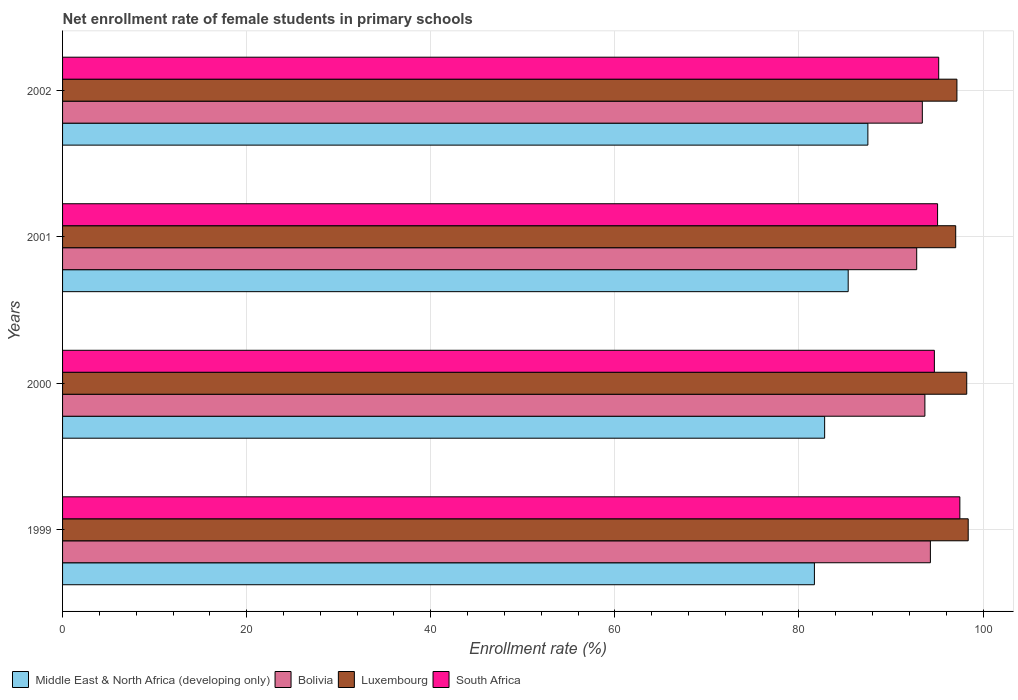How many different coloured bars are there?
Your answer should be compact. 4. How many groups of bars are there?
Your response must be concise. 4. How many bars are there on the 3rd tick from the top?
Your answer should be compact. 4. What is the label of the 3rd group of bars from the top?
Keep it short and to the point. 2000. What is the net enrollment rate of female students in primary schools in Middle East & North Africa (developing only) in 2000?
Offer a very short reply. 82.79. Across all years, what is the maximum net enrollment rate of female students in primary schools in Bolivia?
Provide a succinct answer. 94.28. Across all years, what is the minimum net enrollment rate of female students in primary schools in South Africa?
Ensure brevity in your answer.  94.71. In which year was the net enrollment rate of female students in primary schools in Middle East & North Africa (developing only) maximum?
Provide a short and direct response. 2002. In which year was the net enrollment rate of female students in primary schools in South Africa minimum?
Provide a succinct answer. 2000. What is the total net enrollment rate of female students in primary schools in Middle East & North Africa (developing only) in the graph?
Your response must be concise. 337.3. What is the difference between the net enrollment rate of female students in primary schools in Luxembourg in 2000 and that in 2001?
Your answer should be very brief. 1.2. What is the difference between the net enrollment rate of female students in primary schools in Luxembourg in 2000 and the net enrollment rate of female students in primary schools in Middle East & North Africa (developing only) in 2002?
Provide a short and direct response. 10.74. What is the average net enrollment rate of female students in primary schools in Luxembourg per year?
Offer a terse response. 97.7. In the year 2001, what is the difference between the net enrollment rate of female students in primary schools in Luxembourg and net enrollment rate of female students in primary schools in Middle East & North Africa (developing only)?
Make the answer very short. 11.68. What is the ratio of the net enrollment rate of female students in primary schools in Bolivia in 1999 to that in 2001?
Keep it short and to the point. 1.02. Is the net enrollment rate of female students in primary schools in Middle East & North Africa (developing only) in 1999 less than that in 2001?
Provide a succinct answer. Yes. Is the difference between the net enrollment rate of female students in primary schools in Luxembourg in 2001 and 2002 greater than the difference between the net enrollment rate of female students in primary schools in Middle East & North Africa (developing only) in 2001 and 2002?
Make the answer very short. Yes. What is the difference between the highest and the second highest net enrollment rate of female students in primary schools in Luxembourg?
Your answer should be very brief. 0.16. What is the difference between the highest and the lowest net enrollment rate of female students in primary schools in Luxembourg?
Give a very brief answer. 1.36. In how many years, is the net enrollment rate of female students in primary schools in Luxembourg greater than the average net enrollment rate of female students in primary schools in Luxembourg taken over all years?
Provide a short and direct response. 2. Is the sum of the net enrollment rate of female students in primary schools in South Africa in 2000 and 2001 greater than the maximum net enrollment rate of female students in primary schools in Middle East & North Africa (developing only) across all years?
Your response must be concise. Yes. What does the 3rd bar from the top in 2002 represents?
Offer a terse response. Bolivia. What does the 3rd bar from the bottom in 1999 represents?
Your answer should be compact. Luxembourg. How many years are there in the graph?
Offer a terse response. 4. What is the difference between two consecutive major ticks on the X-axis?
Your response must be concise. 20. Does the graph contain grids?
Ensure brevity in your answer.  Yes. Where does the legend appear in the graph?
Offer a very short reply. Bottom left. How many legend labels are there?
Keep it short and to the point. 4. What is the title of the graph?
Keep it short and to the point. Net enrollment rate of female students in primary schools. Does "Switzerland" appear as one of the legend labels in the graph?
Make the answer very short. No. What is the label or title of the X-axis?
Make the answer very short. Enrollment rate (%). What is the label or title of the Y-axis?
Your response must be concise. Years. What is the Enrollment rate (%) of Middle East & North Africa (developing only) in 1999?
Provide a succinct answer. 81.68. What is the Enrollment rate (%) of Bolivia in 1999?
Make the answer very short. 94.28. What is the Enrollment rate (%) in Luxembourg in 1999?
Offer a very short reply. 98.39. What is the Enrollment rate (%) in South Africa in 1999?
Ensure brevity in your answer.  97.48. What is the Enrollment rate (%) in Middle East & North Africa (developing only) in 2000?
Your answer should be very brief. 82.79. What is the Enrollment rate (%) in Bolivia in 2000?
Provide a succinct answer. 93.68. What is the Enrollment rate (%) of Luxembourg in 2000?
Provide a short and direct response. 98.23. What is the Enrollment rate (%) in South Africa in 2000?
Provide a short and direct response. 94.71. What is the Enrollment rate (%) of Middle East & North Africa (developing only) in 2001?
Make the answer very short. 85.35. What is the Enrollment rate (%) of Bolivia in 2001?
Offer a very short reply. 92.79. What is the Enrollment rate (%) of Luxembourg in 2001?
Your answer should be very brief. 97.03. What is the Enrollment rate (%) in South Africa in 2001?
Keep it short and to the point. 95.06. What is the Enrollment rate (%) in Middle East & North Africa (developing only) in 2002?
Offer a very short reply. 87.49. What is the Enrollment rate (%) of Bolivia in 2002?
Make the answer very short. 93.4. What is the Enrollment rate (%) in Luxembourg in 2002?
Your answer should be compact. 97.16. What is the Enrollment rate (%) of South Africa in 2002?
Keep it short and to the point. 95.18. Across all years, what is the maximum Enrollment rate (%) of Middle East & North Africa (developing only)?
Provide a short and direct response. 87.49. Across all years, what is the maximum Enrollment rate (%) in Bolivia?
Your answer should be very brief. 94.28. Across all years, what is the maximum Enrollment rate (%) in Luxembourg?
Offer a very short reply. 98.39. Across all years, what is the maximum Enrollment rate (%) of South Africa?
Make the answer very short. 97.48. Across all years, what is the minimum Enrollment rate (%) in Middle East & North Africa (developing only)?
Ensure brevity in your answer.  81.68. Across all years, what is the minimum Enrollment rate (%) of Bolivia?
Give a very brief answer. 92.79. Across all years, what is the minimum Enrollment rate (%) in Luxembourg?
Your response must be concise. 97.03. Across all years, what is the minimum Enrollment rate (%) of South Africa?
Keep it short and to the point. 94.71. What is the total Enrollment rate (%) of Middle East & North Africa (developing only) in the graph?
Ensure brevity in your answer.  337.3. What is the total Enrollment rate (%) of Bolivia in the graph?
Offer a terse response. 374.16. What is the total Enrollment rate (%) in Luxembourg in the graph?
Your response must be concise. 390.8. What is the total Enrollment rate (%) of South Africa in the graph?
Provide a short and direct response. 382.43. What is the difference between the Enrollment rate (%) in Middle East & North Africa (developing only) in 1999 and that in 2000?
Give a very brief answer. -1.11. What is the difference between the Enrollment rate (%) of Bolivia in 1999 and that in 2000?
Provide a short and direct response. 0.6. What is the difference between the Enrollment rate (%) in Luxembourg in 1999 and that in 2000?
Ensure brevity in your answer.  0.16. What is the difference between the Enrollment rate (%) of South Africa in 1999 and that in 2000?
Keep it short and to the point. 2.77. What is the difference between the Enrollment rate (%) in Middle East & North Africa (developing only) in 1999 and that in 2001?
Make the answer very short. -3.67. What is the difference between the Enrollment rate (%) of Bolivia in 1999 and that in 2001?
Your answer should be compact. 1.49. What is the difference between the Enrollment rate (%) in Luxembourg in 1999 and that in 2001?
Your answer should be very brief. 1.36. What is the difference between the Enrollment rate (%) in South Africa in 1999 and that in 2001?
Your response must be concise. 2.42. What is the difference between the Enrollment rate (%) in Middle East & North Africa (developing only) in 1999 and that in 2002?
Your answer should be compact. -5.81. What is the difference between the Enrollment rate (%) of Bolivia in 1999 and that in 2002?
Your answer should be compact. 0.88. What is the difference between the Enrollment rate (%) in Luxembourg in 1999 and that in 2002?
Provide a succinct answer. 1.23. What is the difference between the Enrollment rate (%) in South Africa in 1999 and that in 2002?
Make the answer very short. 2.3. What is the difference between the Enrollment rate (%) in Middle East & North Africa (developing only) in 2000 and that in 2001?
Ensure brevity in your answer.  -2.56. What is the difference between the Enrollment rate (%) of Bolivia in 2000 and that in 2001?
Your answer should be very brief. 0.89. What is the difference between the Enrollment rate (%) in Luxembourg in 2000 and that in 2001?
Provide a succinct answer. 1.2. What is the difference between the Enrollment rate (%) of South Africa in 2000 and that in 2001?
Offer a very short reply. -0.35. What is the difference between the Enrollment rate (%) of Middle East & North Africa (developing only) in 2000 and that in 2002?
Your answer should be compact. -4.7. What is the difference between the Enrollment rate (%) in Bolivia in 2000 and that in 2002?
Your answer should be compact. 0.28. What is the difference between the Enrollment rate (%) in Luxembourg in 2000 and that in 2002?
Your response must be concise. 1.07. What is the difference between the Enrollment rate (%) of South Africa in 2000 and that in 2002?
Your answer should be compact. -0.47. What is the difference between the Enrollment rate (%) of Middle East & North Africa (developing only) in 2001 and that in 2002?
Offer a terse response. -2.14. What is the difference between the Enrollment rate (%) in Bolivia in 2001 and that in 2002?
Ensure brevity in your answer.  -0.61. What is the difference between the Enrollment rate (%) in Luxembourg in 2001 and that in 2002?
Ensure brevity in your answer.  -0.13. What is the difference between the Enrollment rate (%) in South Africa in 2001 and that in 2002?
Your response must be concise. -0.12. What is the difference between the Enrollment rate (%) in Middle East & North Africa (developing only) in 1999 and the Enrollment rate (%) in Bolivia in 2000?
Offer a terse response. -12. What is the difference between the Enrollment rate (%) in Middle East & North Africa (developing only) in 1999 and the Enrollment rate (%) in Luxembourg in 2000?
Your answer should be very brief. -16.55. What is the difference between the Enrollment rate (%) of Middle East & North Africa (developing only) in 1999 and the Enrollment rate (%) of South Africa in 2000?
Provide a short and direct response. -13.03. What is the difference between the Enrollment rate (%) of Bolivia in 1999 and the Enrollment rate (%) of Luxembourg in 2000?
Your answer should be very brief. -3.95. What is the difference between the Enrollment rate (%) of Bolivia in 1999 and the Enrollment rate (%) of South Africa in 2000?
Give a very brief answer. -0.43. What is the difference between the Enrollment rate (%) of Luxembourg in 1999 and the Enrollment rate (%) of South Africa in 2000?
Your answer should be very brief. 3.68. What is the difference between the Enrollment rate (%) in Middle East & North Africa (developing only) in 1999 and the Enrollment rate (%) in Bolivia in 2001?
Provide a short and direct response. -11.11. What is the difference between the Enrollment rate (%) of Middle East & North Africa (developing only) in 1999 and the Enrollment rate (%) of Luxembourg in 2001?
Give a very brief answer. -15.35. What is the difference between the Enrollment rate (%) of Middle East & North Africa (developing only) in 1999 and the Enrollment rate (%) of South Africa in 2001?
Provide a succinct answer. -13.38. What is the difference between the Enrollment rate (%) in Bolivia in 1999 and the Enrollment rate (%) in Luxembourg in 2001?
Provide a short and direct response. -2.75. What is the difference between the Enrollment rate (%) of Bolivia in 1999 and the Enrollment rate (%) of South Africa in 2001?
Your response must be concise. -0.78. What is the difference between the Enrollment rate (%) of Luxembourg in 1999 and the Enrollment rate (%) of South Africa in 2001?
Offer a terse response. 3.33. What is the difference between the Enrollment rate (%) in Middle East & North Africa (developing only) in 1999 and the Enrollment rate (%) in Bolivia in 2002?
Your response must be concise. -11.72. What is the difference between the Enrollment rate (%) of Middle East & North Africa (developing only) in 1999 and the Enrollment rate (%) of Luxembourg in 2002?
Keep it short and to the point. -15.48. What is the difference between the Enrollment rate (%) of Middle East & North Africa (developing only) in 1999 and the Enrollment rate (%) of South Africa in 2002?
Make the answer very short. -13.5. What is the difference between the Enrollment rate (%) of Bolivia in 1999 and the Enrollment rate (%) of Luxembourg in 2002?
Ensure brevity in your answer.  -2.88. What is the difference between the Enrollment rate (%) in Bolivia in 1999 and the Enrollment rate (%) in South Africa in 2002?
Your answer should be compact. -0.9. What is the difference between the Enrollment rate (%) in Luxembourg in 1999 and the Enrollment rate (%) in South Africa in 2002?
Make the answer very short. 3.21. What is the difference between the Enrollment rate (%) of Middle East & North Africa (developing only) in 2000 and the Enrollment rate (%) of Bolivia in 2001?
Provide a succinct answer. -10. What is the difference between the Enrollment rate (%) of Middle East & North Africa (developing only) in 2000 and the Enrollment rate (%) of Luxembourg in 2001?
Give a very brief answer. -14.24. What is the difference between the Enrollment rate (%) of Middle East & North Africa (developing only) in 2000 and the Enrollment rate (%) of South Africa in 2001?
Provide a succinct answer. -12.27. What is the difference between the Enrollment rate (%) of Bolivia in 2000 and the Enrollment rate (%) of Luxembourg in 2001?
Give a very brief answer. -3.35. What is the difference between the Enrollment rate (%) of Bolivia in 2000 and the Enrollment rate (%) of South Africa in 2001?
Make the answer very short. -1.38. What is the difference between the Enrollment rate (%) of Luxembourg in 2000 and the Enrollment rate (%) of South Africa in 2001?
Provide a succinct answer. 3.17. What is the difference between the Enrollment rate (%) in Middle East & North Africa (developing only) in 2000 and the Enrollment rate (%) in Bolivia in 2002?
Your response must be concise. -10.61. What is the difference between the Enrollment rate (%) in Middle East & North Africa (developing only) in 2000 and the Enrollment rate (%) in Luxembourg in 2002?
Give a very brief answer. -14.37. What is the difference between the Enrollment rate (%) in Middle East & North Africa (developing only) in 2000 and the Enrollment rate (%) in South Africa in 2002?
Your answer should be very brief. -12.39. What is the difference between the Enrollment rate (%) of Bolivia in 2000 and the Enrollment rate (%) of Luxembourg in 2002?
Provide a short and direct response. -3.48. What is the difference between the Enrollment rate (%) in Bolivia in 2000 and the Enrollment rate (%) in South Africa in 2002?
Your answer should be compact. -1.5. What is the difference between the Enrollment rate (%) of Luxembourg in 2000 and the Enrollment rate (%) of South Africa in 2002?
Provide a succinct answer. 3.04. What is the difference between the Enrollment rate (%) in Middle East & North Africa (developing only) in 2001 and the Enrollment rate (%) in Bolivia in 2002?
Make the answer very short. -8.05. What is the difference between the Enrollment rate (%) in Middle East & North Africa (developing only) in 2001 and the Enrollment rate (%) in Luxembourg in 2002?
Your answer should be compact. -11.81. What is the difference between the Enrollment rate (%) in Middle East & North Africa (developing only) in 2001 and the Enrollment rate (%) in South Africa in 2002?
Keep it short and to the point. -9.83. What is the difference between the Enrollment rate (%) of Bolivia in 2001 and the Enrollment rate (%) of Luxembourg in 2002?
Offer a terse response. -4.37. What is the difference between the Enrollment rate (%) in Bolivia in 2001 and the Enrollment rate (%) in South Africa in 2002?
Give a very brief answer. -2.39. What is the difference between the Enrollment rate (%) in Luxembourg in 2001 and the Enrollment rate (%) in South Africa in 2002?
Make the answer very short. 1.85. What is the average Enrollment rate (%) of Middle East & North Africa (developing only) per year?
Offer a very short reply. 84.33. What is the average Enrollment rate (%) of Bolivia per year?
Provide a short and direct response. 93.54. What is the average Enrollment rate (%) of Luxembourg per year?
Make the answer very short. 97.7. What is the average Enrollment rate (%) in South Africa per year?
Offer a terse response. 95.61. In the year 1999, what is the difference between the Enrollment rate (%) in Middle East & North Africa (developing only) and Enrollment rate (%) in Bolivia?
Keep it short and to the point. -12.6. In the year 1999, what is the difference between the Enrollment rate (%) in Middle East & North Africa (developing only) and Enrollment rate (%) in Luxembourg?
Offer a very short reply. -16.71. In the year 1999, what is the difference between the Enrollment rate (%) of Middle East & North Africa (developing only) and Enrollment rate (%) of South Africa?
Your answer should be compact. -15.8. In the year 1999, what is the difference between the Enrollment rate (%) of Bolivia and Enrollment rate (%) of Luxembourg?
Keep it short and to the point. -4.11. In the year 1999, what is the difference between the Enrollment rate (%) of Bolivia and Enrollment rate (%) of South Africa?
Make the answer very short. -3.2. In the year 1999, what is the difference between the Enrollment rate (%) in Luxembourg and Enrollment rate (%) in South Africa?
Give a very brief answer. 0.91. In the year 2000, what is the difference between the Enrollment rate (%) of Middle East & North Africa (developing only) and Enrollment rate (%) of Bolivia?
Give a very brief answer. -10.89. In the year 2000, what is the difference between the Enrollment rate (%) in Middle East & North Africa (developing only) and Enrollment rate (%) in Luxembourg?
Your answer should be very brief. -15.44. In the year 2000, what is the difference between the Enrollment rate (%) of Middle East & North Africa (developing only) and Enrollment rate (%) of South Africa?
Give a very brief answer. -11.92. In the year 2000, what is the difference between the Enrollment rate (%) of Bolivia and Enrollment rate (%) of Luxembourg?
Offer a terse response. -4.55. In the year 2000, what is the difference between the Enrollment rate (%) of Bolivia and Enrollment rate (%) of South Africa?
Make the answer very short. -1.03. In the year 2000, what is the difference between the Enrollment rate (%) in Luxembourg and Enrollment rate (%) in South Africa?
Give a very brief answer. 3.52. In the year 2001, what is the difference between the Enrollment rate (%) in Middle East & North Africa (developing only) and Enrollment rate (%) in Bolivia?
Offer a very short reply. -7.44. In the year 2001, what is the difference between the Enrollment rate (%) of Middle East & North Africa (developing only) and Enrollment rate (%) of Luxembourg?
Your answer should be very brief. -11.68. In the year 2001, what is the difference between the Enrollment rate (%) in Middle East & North Africa (developing only) and Enrollment rate (%) in South Africa?
Your answer should be compact. -9.71. In the year 2001, what is the difference between the Enrollment rate (%) of Bolivia and Enrollment rate (%) of Luxembourg?
Offer a very short reply. -4.24. In the year 2001, what is the difference between the Enrollment rate (%) in Bolivia and Enrollment rate (%) in South Africa?
Offer a terse response. -2.27. In the year 2001, what is the difference between the Enrollment rate (%) of Luxembourg and Enrollment rate (%) of South Africa?
Your answer should be very brief. 1.97. In the year 2002, what is the difference between the Enrollment rate (%) of Middle East & North Africa (developing only) and Enrollment rate (%) of Bolivia?
Provide a succinct answer. -5.92. In the year 2002, what is the difference between the Enrollment rate (%) in Middle East & North Africa (developing only) and Enrollment rate (%) in Luxembourg?
Ensure brevity in your answer.  -9.67. In the year 2002, what is the difference between the Enrollment rate (%) in Middle East & North Africa (developing only) and Enrollment rate (%) in South Africa?
Offer a terse response. -7.7. In the year 2002, what is the difference between the Enrollment rate (%) of Bolivia and Enrollment rate (%) of Luxembourg?
Offer a very short reply. -3.76. In the year 2002, what is the difference between the Enrollment rate (%) of Bolivia and Enrollment rate (%) of South Africa?
Ensure brevity in your answer.  -1.78. In the year 2002, what is the difference between the Enrollment rate (%) of Luxembourg and Enrollment rate (%) of South Africa?
Give a very brief answer. 1.98. What is the ratio of the Enrollment rate (%) of Middle East & North Africa (developing only) in 1999 to that in 2000?
Keep it short and to the point. 0.99. What is the ratio of the Enrollment rate (%) in Bolivia in 1999 to that in 2000?
Give a very brief answer. 1.01. What is the ratio of the Enrollment rate (%) in South Africa in 1999 to that in 2000?
Offer a terse response. 1.03. What is the ratio of the Enrollment rate (%) in Middle East & North Africa (developing only) in 1999 to that in 2001?
Make the answer very short. 0.96. What is the ratio of the Enrollment rate (%) in Bolivia in 1999 to that in 2001?
Offer a very short reply. 1.02. What is the ratio of the Enrollment rate (%) in Luxembourg in 1999 to that in 2001?
Your response must be concise. 1.01. What is the ratio of the Enrollment rate (%) of South Africa in 1999 to that in 2001?
Your response must be concise. 1.03. What is the ratio of the Enrollment rate (%) in Middle East & North Africa (developing only) in 1999 to that in 2002?
Give a very brief answer. 0.93. What is the ratio of the Enrollment rate (%) of Bolivia in 1999 to that in 2002?
Ensure brevity in your answer.  1.01. What is the ratio of the Enrollment rate (%) of Luxembourg in 1999 to that in 2002?
Offer a very short reply. 1.01. What is the ratio of the Enrollment rate (%) of South Africa in 1999 to that in 2002?
Offer a terse response. 1.02. What is the ratio of the Enrollment rate (%) in Middle East & North Africa (developing only) in 2000 to that in 2001?
Your answer should be very brief. 0.97. What is the ratio of the Enrollment rate (%) of Bolivia in 2000 to that in 2001?
Make the answer very short. 1.01. What is the ratio of the Enrollment rate (%) of Luxembourg in 2000 to that in 2001?
Offer a very short reply. 1.01. What is the ratio of the Enrollment rate (%) in Middle East & North Africa (developing only) in 2000 to that in 2002?
Your answer should be compact. 0.95. What is the ratio of the Enrollment rate (%) in Bolivia in 2000 to that in 2002?
Your answer should be very brief. 1. What is the ratio of the Enrollment rate (%) in Luxembourg in 2000 to that in 2002?
Keep it short and to the point. 1.01. What is the ratio of the Enrollment rate (%) in Middle East & North Africa (developing only) in 2001 to that in 2002?
Provide a short and direct response. 0.98. What is the ratio of the Enrollment rate (%) of Luxembourg in 2001 to that in 2002?
Your answer should be compact. 1. What is the ratio of the Enrollment rate (%) of South Africa in 2001 to that in 2002?
Provide a short and direct response. 1. What is the difference between the highest and the second highest Enrollment rate (%) of Middle East & North Africa (developing only)?
Offer a very short reply. 2.14. What is the difference between the highest and the second highest Enrollment rate (%) of Bolivia?
Offer a very short reply. 0.6. What is the difference between the highest and the second highest Enrollment rate (%) in Luxembourg?
Ensure brevity in your answer.  0.16. What is the difference between the highest and the second highest Enrollment rate (%) of South Africa?
Provide a succinct answer. 2.3. What is the difference between the highest and the lowest Enrollment rate (%) in Middle East & North Africa (developing only)?
Your response must be concise. 5.81. What is the difference between the highest and the lowest Enrollment rate (%) of Bolivia?
Your answer should be very brief. 1.49. What is the difference between the highest and the lowest Enrollment rate (%) of Luxembourg?
Your response must be concise. 1.36. What is the difference between the highest and the lowest Enrollment rate (%) in South Africa?
Ensure brevity in your answer.  2.77. 